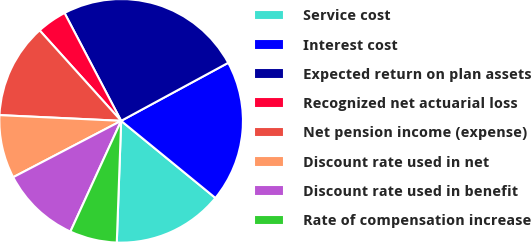Convert chart. <chart><loc_0><loc_0><loc_500><loc_500><pie_chart><fcel>Service cost<fcel>Interest cost<fcel>Expected return on plan assets<fcel>Recognized net actuarial loss<fcel>Net pension income (expense)<fcel>Discount rate used in net<fcel>Discount rate used in benefit<fcel>Rate of compensation increase<nl><fcel>14.66%<fcel>18.82%<fcel>24.79%<fcel>3.98%<fcel>12.58%<fcel>8.41%<fcel>10.5%<fcel>6.27%<nl></chart> 